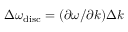<formula> <loc_0><loc_0><loc_500><loc_500>\Delta \omega _ { d i s c } = ( \partial \omega / \partial k ) \Delta k</formula> 